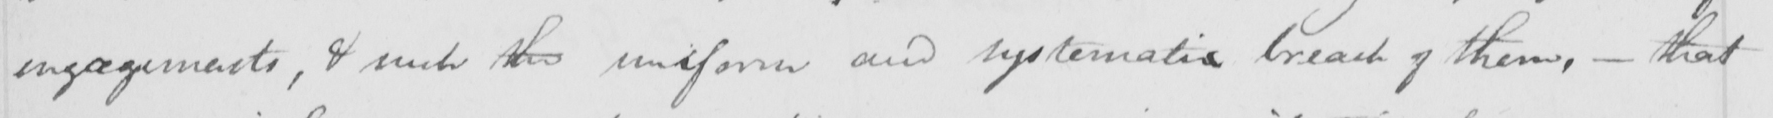What does this handwritten line say? engagements , & such the uniform and systematic breach of them ,  _  that 